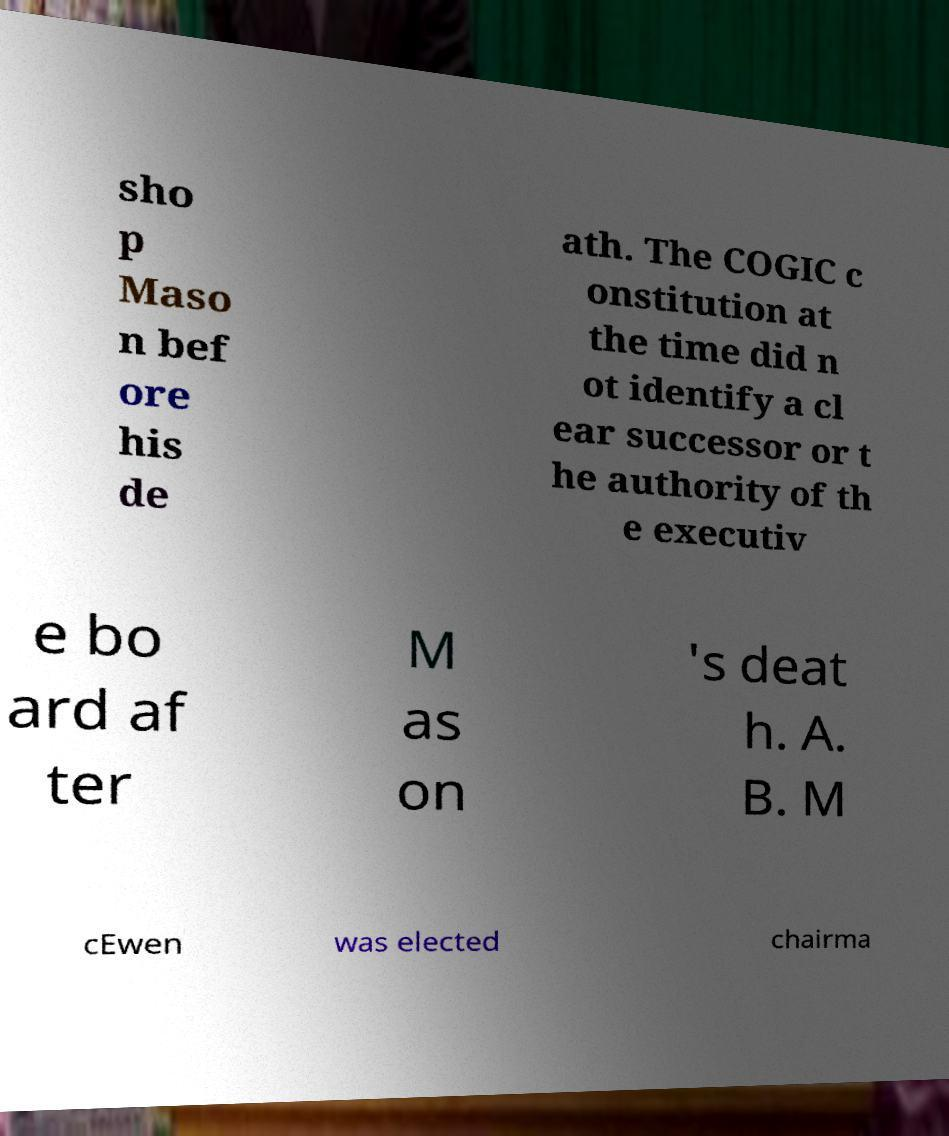Can you read and provide the text displayed in the image?This photo seems to have some interesting text. Can you extract and type it out for me? sho p Maso n bef ore his de ath. The COGIC c onstitution at the time did n ot identify a cl ear successor or t he authority of th e executiv e bo ard af ter M as on 's deat h. A. B. M cEwen was elected chairma 